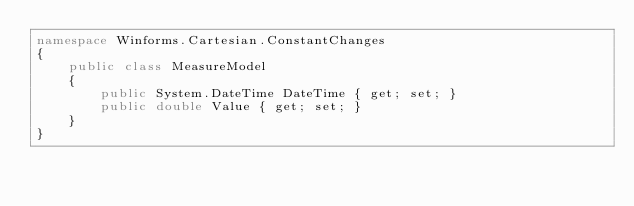<code> <loc_0><loc_0><loc_500><loc_500><_C#_>namespace Winforms.Cartesian.ConstantChanges
{
    public class MeasureModel
    {
        public System.DateTime DateTime { get; set; }
        public double Value { get; set; }
    }
}
</code> 